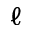<formula> <loc_0><loc_0><loc_500><loc_500>\ell</formula> 